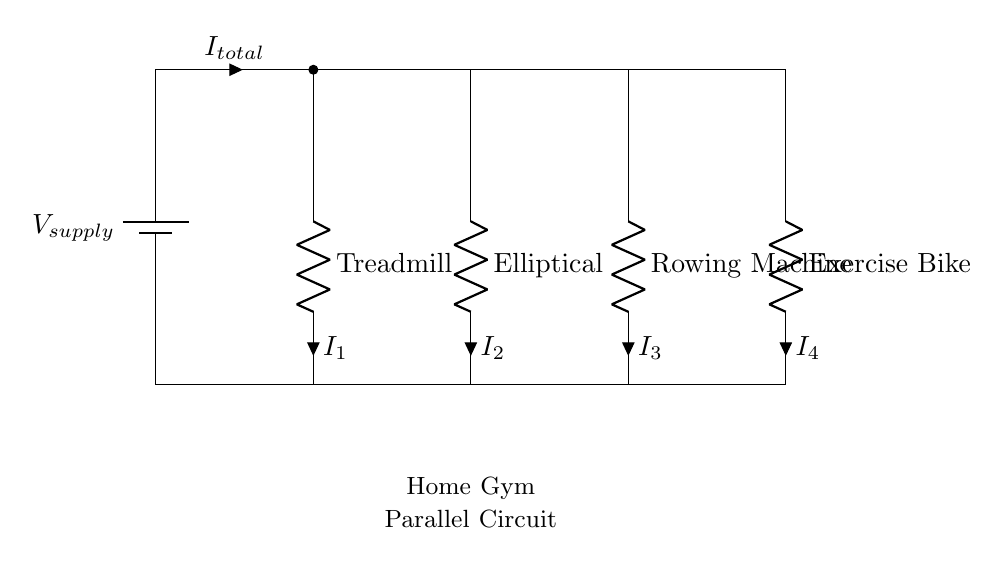What is the total current flowing from the battery? The total current can be identified as "I_total," which is the current flowing from the battery to the parallel branches. Since all devices are connected in parallel, the total current supplied by the battery is the sum of the currents through each parallel component.
Answer: I_total How many exercise machines are connected in parallel? By examining the diagram, there are four resistance components labeled for different exercise machines: Treadmill, Elliptical, Rowing Machine, and Exercise Bike. Therefore, there are four machines connected in parallel.
Answer: 4 What is the configuration of the circuit diagram? The circuit diagram shows a parallel configuration, meaning all components are connected across the same two voltage points, allowing them to operate independently of each other. This arrangement is typical when multiple devices can be powered by the same source.
Answer: Parallel What type of circuit component is used for each exercise machine? Each exercise machine is represented by a resistor labeled with its name, indicating that they are modeled as resistive loads within the electrical system. Resistors are typically used in circuit diagrams to represent devices that consume power.
Answer: Resistor How does the current behave in this parallel circuit? In a parallel circuit, the voltage across each component is the same, allowing the current to divide among the branches according to their resistances. Each exercise machine receives the same supply voltage, but the individual currents will vary based on the resistance of each machine.
Answer: Divides What is the voltage provided by the source? The circuit indicates a single voltage source labeled "V_supply," which is not quantified in the diagram but can typically be regarded as a constant value depending on the specific power supply used. It's often a fixed voltage in home gym setups.
Answer: V_supply How are the currents through each machine related? The currents through each machine (I_1, I_2, I_3, and I_4) are related to the total current (I_total) as they add up to that total current in a parallel configuration. This relationship is described by the equation I_total = I_1 + I_2 + I_3 + I_4.
Answer: Sum of currents 